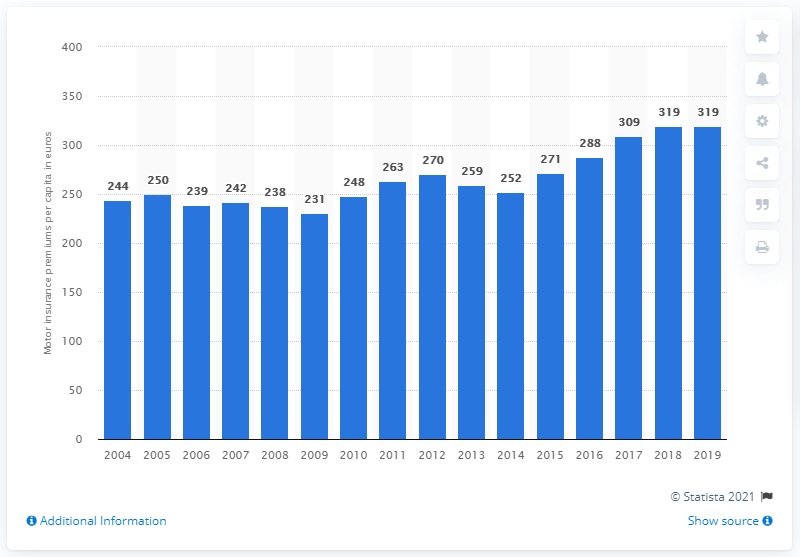In what year did the average premium per capita increase by 319 euros? The average premium per capita increased by 319 euros in the year 2017. This significant rise can be observed on the bar graph where the number shown atop the bar for 2017 noticeably jumps from the previous year's figure. 